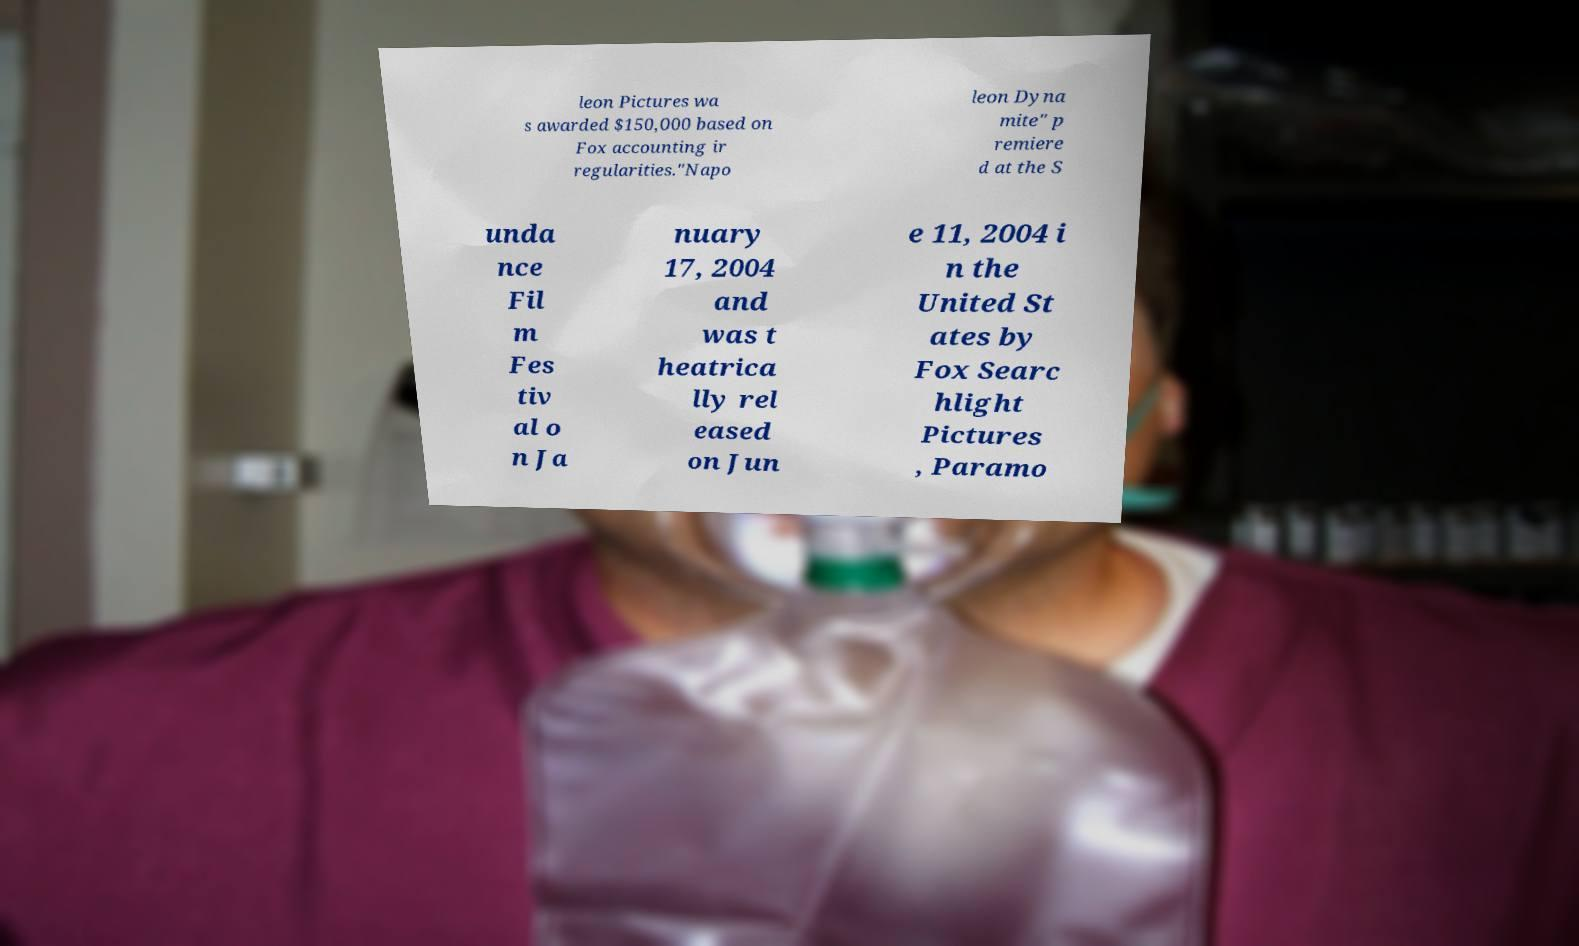I need the written content from this picture converted into text. Can you do that? leon Pictures wa s awarded $150,000 based on Fox accounting ir regularities."Napo leon Dyna mite" p remiere d at the S unda nce Fil m Fes tiv al o n Ja nuary 17, 2004 and was t heatrica lly rel eased on Jun e 11, 2004 i n the United St ates by Fox Searc hlight Pictures , Paramo 